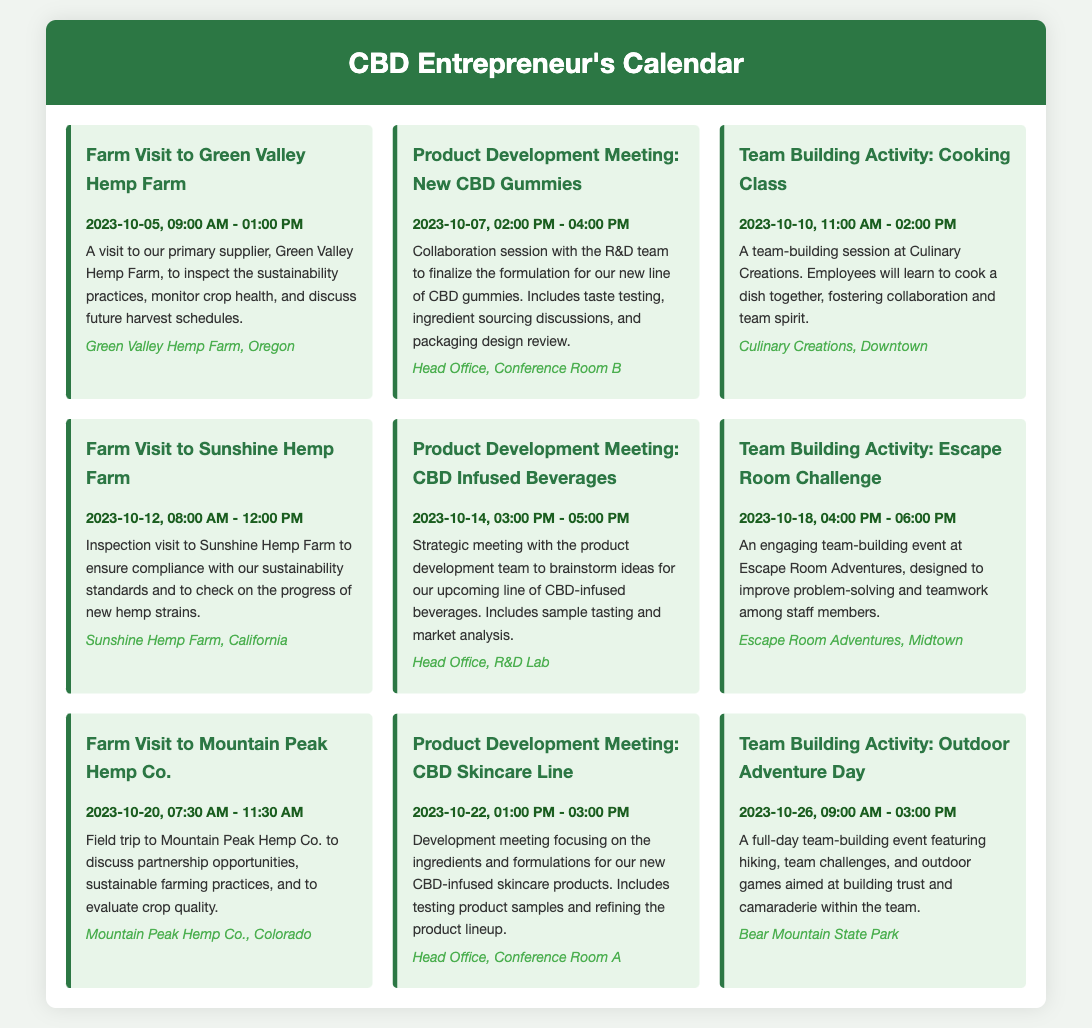what is the date of the first farm visit? The first farm visit is scheduled for October 5th, 2023.
Answer: October 5, 2023 what is the location of the team-building activity on October 10th? The location for the team-building activity on October 10th is Culinary Creations, Downtown.
Answer: Culinary Creations, Downtown how long is the product development meeting on October 7th? The product development meeting on October 7th is scheduled for 2 hours, from 2:00 PM to 4:00 PM.
Answer: 2 hours which farm will be visited on October 20th? The farm to be visited on October 20th is Mountain Peak Hemp Co.
Answer: Mountain Peak Hemp Co how many team-building activities are scheduled for October? There are three team-building activities scheduled for October.
Answer: three what is the purpose of the October 14th meeting? The purpose of the October 14th meeting is to brainstorm ideas for a line of CBD-infused beverages.
Answer: brainstorm ideas for CBD-infused beverages when is the last scheduled event in this calendar? The last scheduled event is on October 26th, 2023.
Answer: October 26, 2023 which farm is associated with the visit on October 12th? The farm associated with the visit on October 12th is Sunshine Hemp Farm.
Answer: Sunshine Hemp Farm how many farm visits are planned in total? There are four farm visits planned in total.
Answer: four 